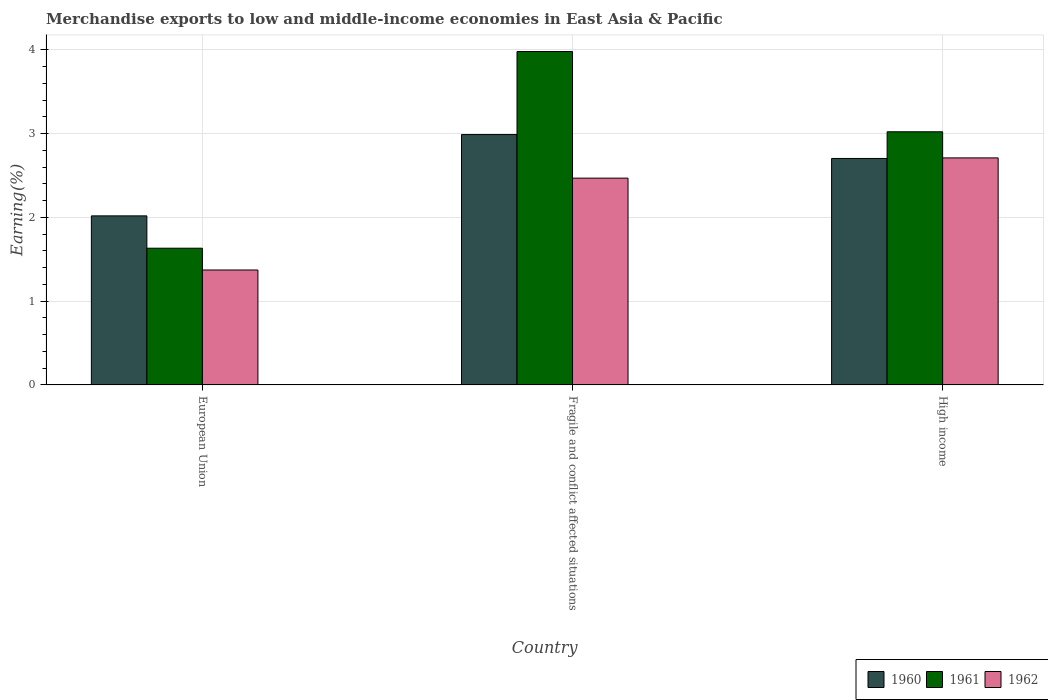Are the number of bars per tick equal to the number of legend labels?
Provide a succinct answer. Yes. How many bars are there on the 3rd tick from the right?
Your answer should be compact. 3. What is the percentage of amount earned from merchandise exports in 1960 in High income?
Your answer should be compact. 2.7. Across all countries, what is the maximum percentage of amount earned from merchandise exports in 1961?
Offer a very short reply. 3.98. Across all countries, what is the minimum percentage of amount earned from merchandise exports in 1961?
Give a very brief answer. 1.63. In which country was the percentage of amount earned from merchandise exports in 1961 maximum?
Give a very brief answer. Fragile and conflict affected situations. In which country was the percentage of amount earned from merchandise exports in 1961 minimum?
Offer a very short reply. European Union. What is the total percentage of amount earned from merchandise exports in 1961 in the graph?
Provide a succinct answer. 8.63. What is the difference between the percentage of amount earned from merchandise exports in 1960 in European Union and that in High income?
Ensure brevity in your answer.  -0.69. What is the difference between the percentage of amount earned from merchandise exports in 1961 in Fragile and conflict affected situations and the percentage of amount earned from merchandise exports in 1962 in European Union?
Provide a short and direct response. 2.61. What is the average percentage of amount earned from merchandise exports in 1961 per country?
Your answer should be compact. 2.88. What is the difference between the percentage of amount earned from merchandise exports of/in 1962 and percentage of amount earned from merchandise exports of/in 1961 in European Union?
Provide a succinct answer. -0.26. In how many countries, is the percentage of amount earned from merchandise exports in 1960 greater than 0.6000000000000001 %?
Make the answer very short. 3. What is the ratio of the percentage of amount earned from merchandise exports in 1960 in Fragile and conflict affected situations to that in High income?
Keep it short and to the point. 1.11. What is the difference between the highest and the second highest percentage of amount earned from merchandise exports in 1960?
Your answer should be very brief. 0.29. What is the difference between the highest and the lowest percentage of amount earned from merchandise exports in 1962?
Provide a short and direct response. 1.34. Is the sum of the percentage of amount earned from merchandise exports in 1961 in European Union and High income greater than the maximum percentage of amount earned from merchandise exports in 1962 across all countries?
Give a very brief answer. Yes. What does the 2nd bar from the left in Fragile and conflict affected situations represents?
Give a very brief answer. 1961. Is it the case that in every country, the sum of the percentage of amount earned from merchandise exports in 1962 and percentage of amount earned from merchandise exports in 1960 is greater than the percentage of amount earned from merchandise exports in 1961?
Your answer should be very brief. Yes. How many countries are there in the graph?
Your response must be concise. 3. Are the values on the major ticks of Y-axis written in scientific E-notation?
Your response must be concise. No. Does the graph contain any zero values?
Your answer should be very brief. No. Does the graph contain grids?
Provide a short and direct response. Yes. What is the title of the graph?
Provide a succinct answer. Merchandise exports to low and middle-income economies in East Asia & Pacific. What is the label or title of the X-axis?
Give a very brief answer. Country. What is the label or title of the Y-axis?
Your answer should be compact. Earning(%). What is the Earning(%) of 1960 in European Union?
Ensure brevity in your answer.  2.02. What is the Earning(%) of 1961 in European Union?
Your answer should be very brief. 1.63. What is the Earning(%) in 1962 in European Union?
Give a very brief answer. 1.37. What is the Earning(%) in 1960 in Fragile and conflict affected situations?
Make the answer very short. 2.99. What is the Earning(%) of 1961 in Fragile and conflict affected situations?
Provide a short and direct response. 3.98. What is the Earning(%) of 1962 in Fragile and conflict affected situations?
Give a very brief answer. 2.47. What is the Earning(%) in 1960 in High income?
Your answer should be very brief. 2.7. What is the Earning(%) in 1961 in High income?
Your answer should be very brief. 3.02. What is the Earning(%) in 1962 in High income?
Your response must be concise. 2.71. Across all countries, what is the maximum Earning(%) in 1960?
Keep it short and to the point. 2.99. Across all countries, what is the maximum Earning(%) of 1961?
Offer a terse response. 3.98. Across all countries, what is the maximum Earning(%) in 1962?
Keep it short and to the point. 2.71. Across all countries, what is the minimum Earning(%) of 1960?
Keep it short and to the point. 2.02. Across all countries, what is the minimum Earning(%) of 1961?
Your answer should be compact. 1.63. Across all countries, what is the minimum Earning(%) of 1962?
Your answer should be very brief. 1.37. What is the total Earning(%) in 1960 in the graph?
Ensure brevity in your answer.  7.71. What is the total Earning(%) in 1961 in the graph?
Give a very brief answer. 8.63. What is the total Earning(%) of 1962 in the graph?
Your answer should be very brief. 6.55. What is the difference between the Earning(%) of 1960 in European Union and that in Fragile and conflict affected situations?
Your answer should be very brief. -0.97. What is the difference between the Earning(%) in 1961 in European Union and that in Fragile and conflict affected situations?
Keep it short and to the point. -2.35. What is the difference between the Earning(%) in 1962 in European Union and that in Fragile and conflict affected situations?
Offer a very short reply. -1.1. What is the difference between the Earning(%) of 1960 in European Union and that in High income?
Keep it short and to the point. -0.69. What is the difference between the Earning(%) of 1961 in European Union and that in High income?
Offer a terse response. -1.39. What is the difference between the Earning(%) of 1962 in European Union and that in High income?
Your answer should be very brief. -1.34. What is the difference between the Earning(%) of 1960 in Fragile and conflict affected situations and that in High income?
Provide a short and direct response. 0.29. What is the difference between the Earning(%) in 1961 in Fragile and conflict affected situations and that in High income?
Provide a short and direct response. 0.96. What is the difference between the Earning(%) in 1962 in Fragile and conflict affected situations and that in High income?
Your response must be concise. -0.24. What is the difference between the Earning(%) in 1960 in European Union and the Earning(%) in 1961 in Fragile and conflict affected situations?
Give a very brief answer. -1.96. What is the difference between the Earning(%) of 1960 in European Union and the Earning(%) of 1962 in Fragile and conflict affected situations?
Give a very brief answer. -0.45. What is the difference between the Earning(%) of 1961 in European Union and the Earning(%) of 1962 in Fragile and conflict affected situations?
Your answer should be very brief. -0.84. What is the difference between the Earning(%) in 1960 in European Union and the Earning(%) in 1961 in High income?
Provide a short and direct response. -1. What is the difference between the Earning(%) in 1960 in European Union and the Earning(%) in 1962 in High income?
Offer a very short reply. -0.69. What is the difference between the Earning(%) in 1961 in European Union and the Earning(%) in 1962 in High income?
Offer a very short reply. -1.08. What is the difference between the Earning(%) in 1960 in Fragile and conflict affected situations and the Earning(%) in 1961 in High income?
Offer a very short reply. -0.03. What is the difference between the Earning(%) in 1960 in Fragile and conflict affected situations and the Earning(%) in 1962 in High income?
Make the answer very short. 0.28. What is the difference between the Earning(%) in 1961 in Fragile and conflict affected situations and the Earning(%) in 1962 in High income?
Your response must be concise. 1.27. What is the average Earning(%) of 1960 per country?
Provide a succinct answer. 2.57. What is the average Earning(%) in 1961 per country?
Your answer should be compact. 2.88. What is the average Earning(%) of 1962 per country?
Your response must be concise. 2.18. What is the difference between the Earning(%) of 1960 and Earning(%) of 1961 in European Union?
Provide a succinct answer. 0.39. What is the difference between the Earning(%) of 1960 and Earning(%) of 1962 in European Union?
Your answer should be compact. 0.65. What is the difference between the Earning(%) of 1961 and Earning(%) of 1962 in European Union?
Offer a terse response. 0.26. What is the difference between the Earning(%) of 1960 and Earning(%) of 1961 in Fragile and conflict affected situations?
Ensure brevity in your answer.  -0.99. What is the difference between the Earning(%) in 1960 and Earning(%) in 1962 in Fragile and conflict affected situations?
Provide a succinct answer. 0.52. What is the difference between the Earning(%) of 1961 and Earning(%) of 1962 in Fragile and conflict affected situations?
Your answer should be compact. 1.51. What is the difference between the Earning(%) in 1960 and Earning(%) in 1961 in High income?
Provide a short and direct response. -0.32. What is the difference between the Earning(%) of 1960 and Earning(%) of 1962 in High income?
Offer a very short reply. -0.01. What is the difference between the Earning(%) in 1961 and Earning(%) in 1962 in High income?
Ensure brevity in your answer.  0.31. What is the ratio of the Earning(%) in 1960 in European Union to that in Fragile and conflict affected situations?
Ensure brevity in your answer.  0.68. What is the ratio of the Earning(%) of 1961 in European Union to that in Fragile and conflict affected situations?
Give a very brief answer. 0.41. What is the ratio of the Earning(%) of 1962 in European Union to that in Fragile and conflict affected situations?
Offer a very short reply. 0.56. What is the ratio of the Earning(%) of 1960 in European Union to that in High income?
Your answer should be very brief. 0.75. What is the ratio of the Earning(%) of 1961 in European Union to that in High income?
Ensure brevity in your answer.  0.54. What is the ratio of the Earning(%) in 1962 in European Union to that in High income?
Give a very brief answer. 0.51. What is the ratio of the Earning(%) in 1960 in Fragile and conflict affected situations to that in High income?
Provide a short and direct response. 1.11. What is the ratio of the Earning(%) in 1961 in Fragile and conflict affected situations to that in High income?
Your response must be concise. 1.32. What is the ratio of the Earning(%) in 1962 in Fragile and conflict affected situations to that in High income?
Offer a very short reply. 0.91. What is the difference between the highest and the second highest Earning(%) in 1960?
Ensure brevity in your answer.  0.29. What is the difference between the highest and the second highest Earning(%) of 1961?
Offer a terse response. 0.96. What is the difference between the highest and the second highest Earning(%) of 1962?
Your response must be concise. 0.24. What is the difference between the highest and the lowest Earning(%) in 1960?
Ensure brevity in your answer.  0.97. What is the difference between the highest and the lowest Earning(%) in 1961?
Offer a terse response. 2.35. What is the difference between the highest and the lowest Earning(%) of 1962?
Ensure brevity in your answer.  1.34. 